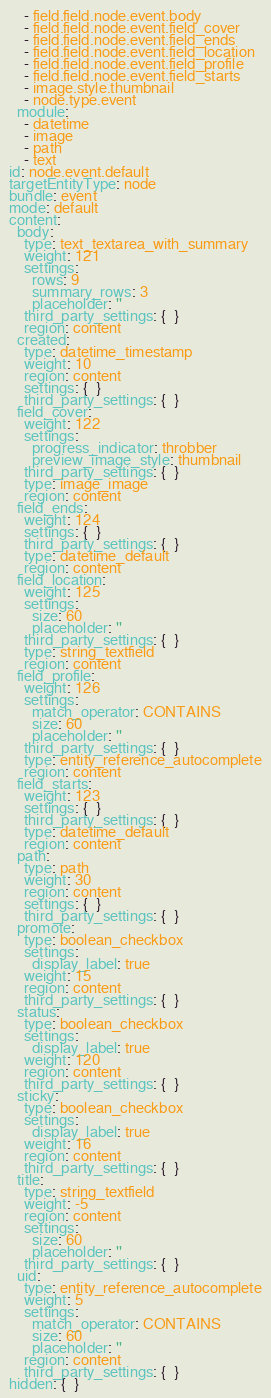<code> <loc_0><loc_0><loc_500><loc_500><_YAML_>    - field.field.node.event.body
    - field.field.node.event.field_cover
    - field.field.node.event.field_ends
    - field.field.node.event.field_location
    - field.field.node.event.field_profile
    - field.field.node.event.field_starts
    - image.style.thumbnail
    - node.type.event
  module:
    - datetime
    - image
    - path
    - text
id: node.event.default
targetEntityType: node
bundle: event
mode: default
content:
  body:
    type: text_textarea_with_summary
    weight: 121
    settings:
      rows: 9
      summary_rows: 3
      placeholder: ''
    third_party_settings: {  }
    region: content
  created:
    type: datetime_timestamp
    weight: 10
    region: content
    settings: {  }
    third_party_settings: {  }
  field_cover:
    weight: 122
    settings:
      progress_indicator: throbber
      preview_image_style: thumbnail
    third_party_settings: {  }
    type: image_image
    region: content
  field_ends:
    weight: 124
    settings: {  }
    third_party_settings: {  }
    type: datetime_default
    region: content
  field_location:
    weight: 125
    settings:
      size: 60
      placeholder: ''
    third_party_settings: {  }
    type: string_textfield
    region: content
  field_profile:
    weight: 126
    settings:
      match_operator: CONTAINS
      size: 60
      placeholder: ''
    third_party_settings: {  }
    type: entity_reference_autocomplete
    region: content
  field_starts:
    weight: 123
    settings: {  }
    third_party_settings: {  }
    type: datetime_default
    region: content
  path:
    type: path
    weight: 30
    region: content
    settings: {  }
    third_party_settings: {  }
  promote:
    type: boolean_checkbox
    settings:
      display_label: true
    weight: 15
    region: content
    third_party_settings: {  }
  status:
    type: boolean_checkbox
    settings:
      display_label: true
    weight: 120
    region: content
    third_party_settings: {  }
  sticky:
    type: boolean_checkbox
    settings:
      display_label: true
    weight: 16
    region: content
    third_party_settings: {  }
  title:
    type: string_textfield
    weight: -5
    region: content
    settings:
      size: 60
      placeholder: ''
    third_party_settings: {  }
  uid:
    type: entity_reference_autocomplete
    weight: 5
    settings:
      match_operator: CONTAINS
      size: 60
      placeholder: ''
    region: content
    third_party_settings: {  }
hidden: {  }
</code> 